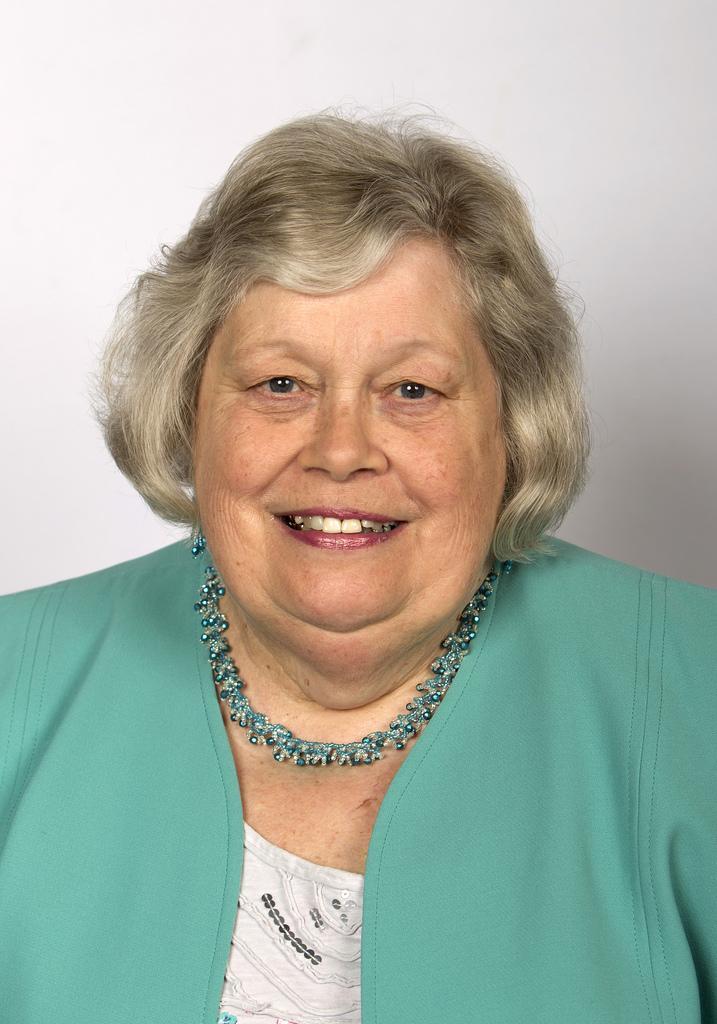In one or two sentences, can you explain what this image depicts? In this picture I can observe a woman in the middle of the picture. She is smiling. The background is in white color. 